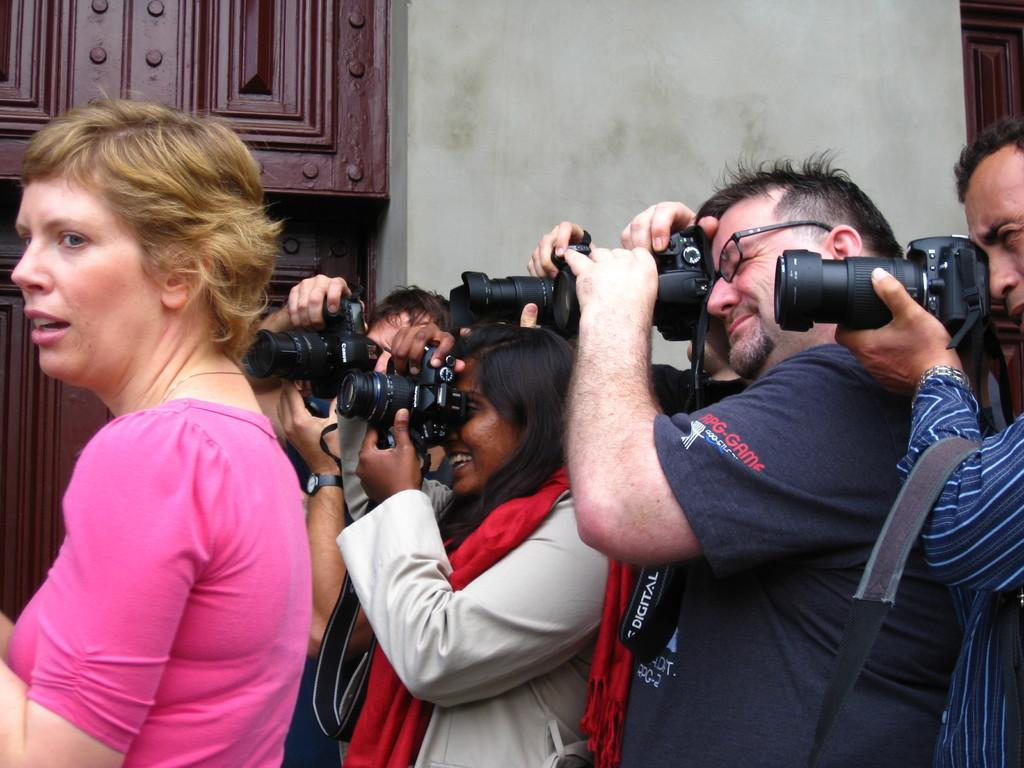Who is present in the image? There is a man and a woman in the image. What are the man and woman doing in the image? Both the man and woman are holding cameras and clicking pictures. What is the position of the woman in the image? The woman is standing in the image. What can be seen in the background of the image? There is a wall and a wooden cupboard in the background of the image. How many minutes does it take for the shelf to appear in the image? There is no shelf present in the image, so it cannot take any minutes for it to appear. 